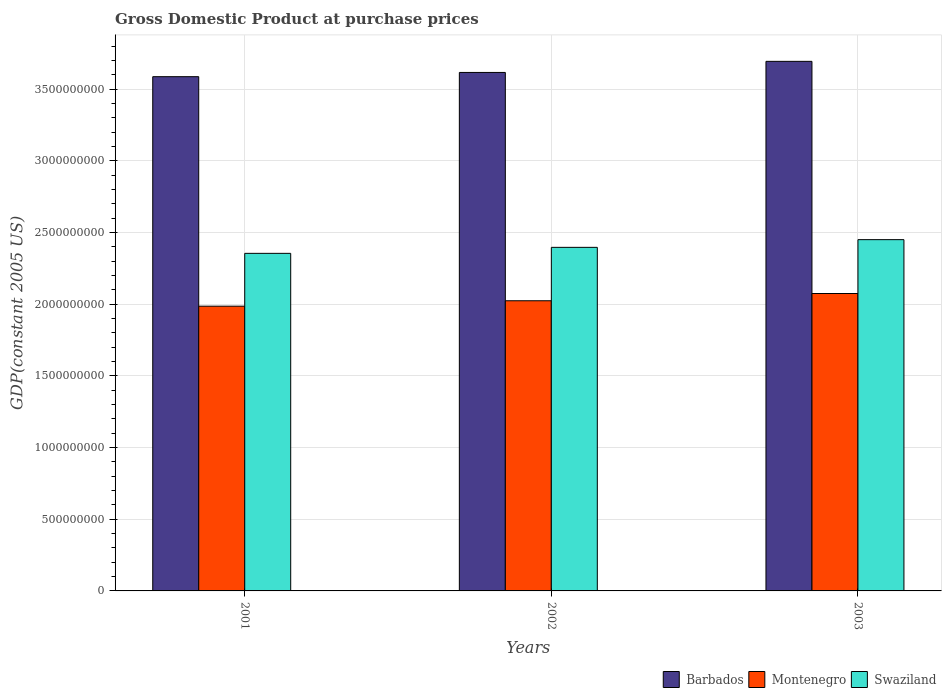Are the number of bars on each tick of the X-axis equal?
Provide a succinct answer. Yes. How many bars are there on the 1st tick from the left?
Your answer should be very brief. 3. In how many cases, is the number of bars for a given year not equal to the number of legend labels?
Your answer should be compact. 0. What is the GDP at purchase prices in Montenegro in 2002?
Give a very brief answer. 2.02e+09. Across all years, what is the maximum GDP at purchase prices in Barbados?
Offer a terse response. 3.69e+09. Across all years, what is the minimum GDP at purchase prices in Montenegro?
Make the answer very short. 1.99e+09. In which year was the GDP at purchase prices in Montenegro maximum?
Ensure brevity in your answer.  2003. What is the total GDP at purchase prices in Barbados in the graph?
Provide a short and direct response. 1.09e+1. What is the difference between the GDP at purchase prices in Montenegro in 2001 and that in 2002?
Provide a succinct answer. -3.77e+07. What is the difference between the GDP at purchase prices in Swaziland in 2003 and the GDP at purchase prices in Montenegro in 2001?
Offer a very short reply. 4.64e+08. What is the average GDP at purchase prices in Barbados per year?
Keep it short and to the point. 3.63e+09. In the year 2003, what is the difference between the GDP at purchase prices in Swaziland and GDP at purchase prices in Barbados?
Ensure brevity in your answer.  -1.24e+09. What is the ratio of the GDP at purchase prices in Barbados in 2001 to that in 2002?
Your response must be concise. 0.99. Is the difference between the GDP at purchase prices in Swaziland in 2001 and 2003 greater than the difference between the GDP at purchase prices in Barbados in 2001 and 2003?
Provide a succinct answer. Yes. What is the difference between the highest and the second highest GDP at purchase prices in Montenegro?
Make the answer very short. 5.06e+07. What is the difference between the highest and the lowest GDP at purchase prices in Montenegro?
Offer a terse response. 8.84e+07. Is the sum of the GDP at purchase prices in Montenegro in 2002 and 2003 greater than the maximum GDP at purchase prices in Barbados across all years?
Your answer should be compact. Yes. What does the 3rd bar from the left in 2003 represents?
Your answer should be compact. Swaziland. What does the 1st bar from the right in 2001 represents?
Provide a succinct answer. Swaziland. How many bars are there?
Provide a succinct answer. 9. Are all the bars in the graph horizontal?
Keep it short and to the point. No. How many years are there in the graph?
Give a very brief answer. 3. Does the graph contain grids?
Make the answer very short. Yes. Where does the legend appear in the graph?
Ensure brevity in your answer.  Bottom right. What is the title of the graph?
Keep it short and to the point. Gross Domestic Product at purchase prices. What is the label or title of the X-axis?
Make the answer very short. Years. What is the label or title of the Y-axis?
Your response must be concise. GDP(constant 2005 US). What is the GDP(constant 2005 US) of Barbados in 2001?
Keep it short and to the point. 3.59e+09. What is the GDP(constant 2005 US) in Montenegro in 2001?
Provide a short and direct response. 1.99e+09. What is the GDP(constant 2005 US) in Swaziland in 2001?
Make the answer very short. 2.36e+09. What is the GDP(constant 2005 US) of Barbados in 2002?
Keep it short and to the point. 3.62e+09. What is the GDP(constant 2005 US) in Montenegro in 2002?
Offer a very short reply. 2.02e+09. What is the GDP(constant 2005 US) of Swaziland in 2002?
Offer a very short reply. 2.40e+09. What is the GDP(constant 2005 US) in Barbados in 2003?
Give a very brief answer. 3.69e+09. What is the GDP(constant 2005 US) of Montenegro in 2003?
Give a very brief answer. 2.07e+09. What is the GDP(constant 2005 US) of Swaziland in 2003?
Your answer should be very brief. 2.45e+09. Across all years, what is the maximum GDP(constant 2005 US) of Barbados?
Keep it short and to the point. 3.69e+09. Across all years, what is the maximum GDP(constant 2005 US) of Montenegro?
Your answer should be very brief. 2.07e+09. Across all years, what is the maximum GDP(constant 2005 US) of Swaziland?
Give a very brief answer. 2.45e+09. Across all years, what is the minimum GDP(constant 2005 US) of Barbados?
Give a very brief answer. 3.59e+09. Across all years, what is the minimum GDP(constant 2005 US) of Montenegro?
Offer a terse response. 1.99e+09. Across all years, what is the minimum GDP(constant 2005 US) of Swaziland?
Make the answer very short. 2.36e+09. What is the total GDP(constant 2005 US) of Barbados in the graph?
Offer a terse response. 1.09e+1. What is the total GDP(constant 2005 US) of Montenegro in the graph?
Offer a terse response. 6.09e+09. What is the total GDP(constant 2005 US) in Swaziland in the graph?
Ensure brevity in your answer.  7.20e+09. What is the difference between the GDP(constant 2005 US) in Barbados in 2001 and that in 2002?
Your response must be concise. -2.95e+07. What is the difference between the GDP(constant 2005 US) of Montenegro in 2001 and that in 2002?
Give a very brief answer. -3.77e+07. What is the difference between the GDP(constant 2005 US) in Swaziland in 2001 and that in 2002?
Give a very brief answer. -4.19e+07. What is the difference between the GDP(constant 2005 US) in Barbados in 2001 and that in 2003?
Your answer should be compact. -1.07e+08. What is the difference between the GDP(constant 2005 US) of Montenegro in 2001 and that in 2003?
Your answer should be very brief. -8.84e+07. What is the difference between the GDP(constant 2005 US) of Swaziland in 2001 and that in 2003?
Your response must be concise. -9.56e+07. What is the difference between the GDP(constant 2005 US) of Barbados in 2002 and that in 2003?
Offer a terse response. -7.74e+07. What is the difference between the GDP(constant 2005 US) of Montenegro in 2002 and that in 2003?
Keep it short and to the point. -5.06e+07. What is the difference between the GDP(constant 2005 US) in Swaziland in 2002 and that in 2003?
Provide a succinct answer. -5.37e+07. What is the difference between the GDP(constant 2005 US) in Barbados in 2001 and the GDP(constant 2005 US) in Montenegro in 2002?
Offer a terse response. 1.56e+09. What is the difference between the GDP(constant 2005 US) of Barbados in 2001 and the GDP(constant 2005 US) of Swaziland in 2002?
Offer a terse response. 1.19e+09. What is the difference between the GDP(constant 2005 US) of Montenegro in 2001 and the GDP(constant 2005 US) of Swaziland in 2002?
Give a very brief answer. -4.10e+08. What is the difference between the GDP(constant 2005 US) in Barbados in 2001 and the GDP(constant 2005 US) in Montenegro in 2003?
Your response must be concise. 1.51e+09. What is the difference between the GDP(constant 2005 US) of Barbados in 2001 and the GDP(constant 2005 US) of Swaziland in 2003?
Offer a terse response. 1.14e+09. What is the difference between the GDP(constant 2005 US) in Montenegro in 2001 and the GDP(constant 2005 US) in Swaziland in 2003?
Your answer should be compact. -4.64e+08. What is the difference between the GDP(constant 2005 US) in Barbados in 2002 and the GDP(constant 2005 US) in Montenegro in 2003?
Keep it short and to the point. 1.54e+09. What is the difference between the GDP(constant 2005 US) in Barbados in 2002 and the GDP(constant 2005 US) in Swaziland in 2003?
Your answer should be compact. 1.17e+09. What is the difference between the GDP(constant 2005 US) in Montenegro in 2002 and the GDP(constant 2005 US) in Swaziland in 2003?
Provide a short and direct response. -4.26e+08. What is the average GDP(constant 2005 US) of Barbados per year?
Ensure brevity in your answer.  3.63e+09. What is the average GDP(constant 2005 US) of Montenegro per year?
Provide a succinct answer. 2.03e+09. What is the average GDP(constant 2005 US) of Swaziland per year?
Make the answer very short. 2.40e+09. In the year 2001, what is the difference between the GDP(constant 2005 US) in Barbados and GDP(constant 2005 US) in Montenegro?
Offer a terse response. 1.60e+09. In the year 2001, what is the difference between the GDP(constant 2005 US) in Barbados and GDP(constant 2005 US) in Swaziland?
Your response must be concise. 1.23e+09. In the year 2001, what is the difference between the GDP(constant 2005 US) of Montenegro and GDP(constant 2005 US) of Swaziland?
Provide a short and direct response. -3.69e+08. In the year 2002, what is the difference between the GDP(constant 2005 US) in Barbados and GDP(constant 2005 US) in Montenegro?
Provide a short and direct response. 1.59e+09. In the year 2002, what is the difference between the GDP(constant 2005 US) of Barbados and GDP(constant 2005 US) of Swaziland?
Make the answer very short. 1.22e+09. In the year 2002, what is the difference between the GDP(constant 2005 US) of Montenegro and GDP(constant 2005 US) of Swaziland?
Give a very brief answer. -3.73e+08. In the year 2003, what is the difference between the GDP(constant 2005 US) of Barbados and GDP(constant 2005 US) of Montenegro?
Keep it short and to the point. 1.62e+09. In the year 2003, what is the difference between the GDP(constant 2005 US) in Barbados and GDP(constant 2005 US) in Swaziland?
Offer a very short reply. 1.24e+09. In the year 2003, what is the difference between the GDP(constant 2005 US) of Montenegro and GDP(constant 2005 US) of Swaziland?
Your answer should be compact. -3.76e+08. What is the ratio of the GDP(constant 2005 US) in Barbados in 2001 to that in 2002?
Make the answer very short. 0.99. What is the ratio of the GDP(constant 2005 US) of Montenegro in 2001 to that in 2002?
Your response must be concise. 0.98. What is the ratio of the GDP(constant 2005 US) in Swaziland in 2001 to that in 2002?
Provide a short and direct response. 0.98. What is the ratio of the GDP(constant 2005 US) in Barbados in 2001 to that in 2003?
Offer a very short reply. 0.97. What is the ratio of the GDP(constant 2005 US) of Montenegro in 2001 to that in 2003?
Provide a short and direct response. 0.96. What is the ratio of the GDP(constant 2005 US) in Swaziland in 2001 to that in 2003?
Offer a very short reply. 0.96. What is the ratio of the GDP(constant 2005 US) of Barbados in 2002 to that in 2003?
Give a very brief answer. 0.98. What is the ratio of the GDP(constant 2005 US) in Montenegro in 2002 to that in 2003?
Offer a very short reply. 0.98. What is the ratio of the GDP(constant 2005 US) of Swaziland in 2002 to that in 2003?
Provide a succinct answer. 0.98. What is the difference between the highest and the second highest GDP(constant 2005 US) of Barbados?
Offer a very short reply. 7.74e+07. What is the difference between the highest and the second highest GDP(constant 2005 US) of Montenegro?
Offer a very short reply. 5.06e+07. What is the difference between the highest and the second highest GDP(constant 2005 US) of Swaziland?
Provide a succinct answer. 5.37e+07. What is the difference between the highest and the lowest GDP(constant 2005 US) of Barbados?
Make the answer very short. 1.07e+08. What is the difference between the highest and the lowest GDP(constant 2005 US) in Montenegro?
Your answer should be very brief. 8.84e+07. What is the difference between the highest and the lowest GDP(constant 2005 US) of Swaziland?
Keep it short and to the point. 9.56e+07. 